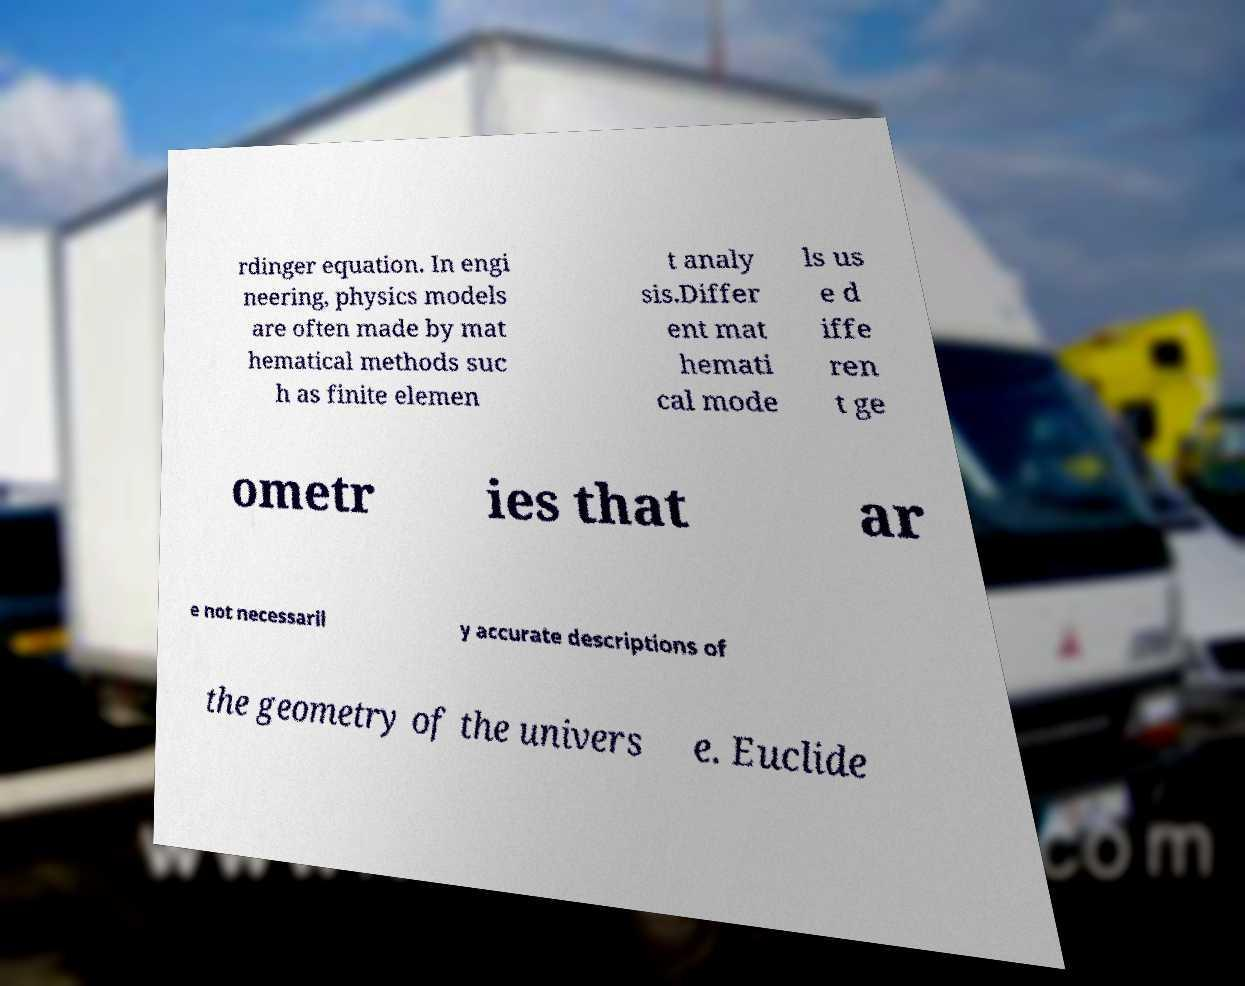What messages or text are displayed in this image? I need them in a readable, typed format. rdinger equation. In engi neering, physics models are often made by mat hematical methods suc h as finite elemen t analy sis.Differ ent mat hemati cal mode ls us e d iffe ren t ge ometr ies that ar e not necessaril y accurate descriptions of the geometry of the univers e. Euclide 